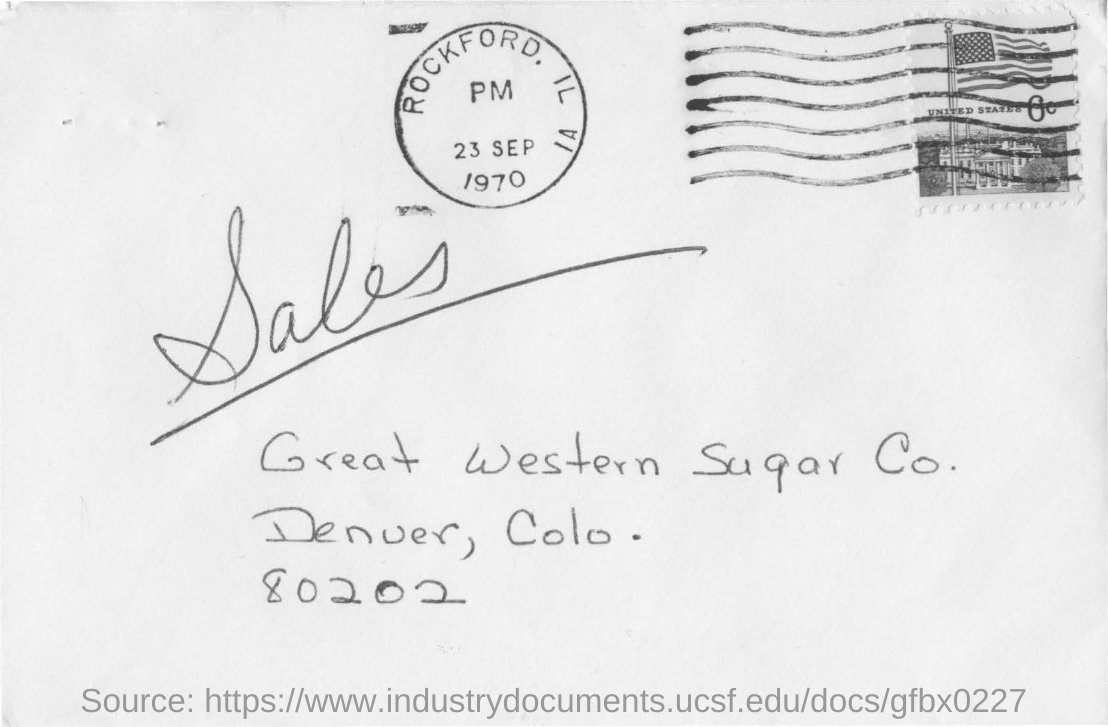What date is seen on the seal at the top of the letter?
Ensure brevity in your answer.  23 SEP 1970. Which  place name is seen on the seal?
Ensure brevity in your answer.  ROCKFORD. Which company address is mentioned on the letter?
Your response must be concise. Great Western Sugar Co. Mention the ZIP code written?
Offer a terse response. 80202. At which place is the Great western sugar Co. located?
Offer a terse response. Denuer, colo. 